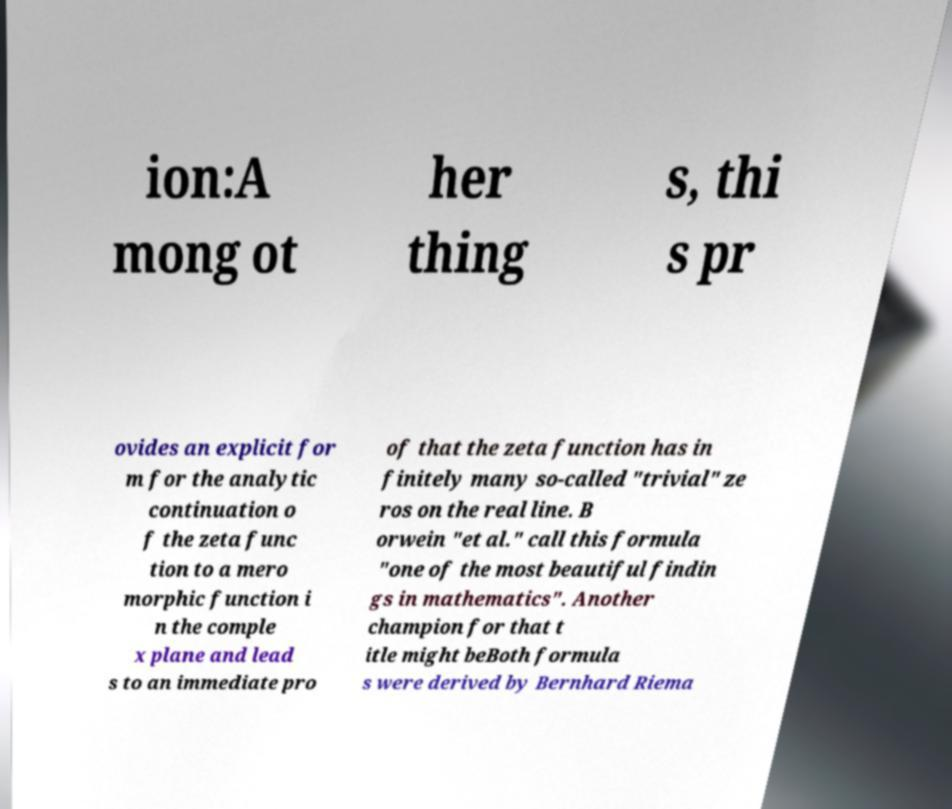For documentation purposes, I need the text within this image transcribed. Could you provide that? ion:A mong ot her thing s, thi s pr ovides an explicit for m for the analytic continuation o f the zeta func tion to a mero morphic function i n the comple x plane and lead s to an immediate pro of that the zeta function has in finitely many so-called "trivial" ze ros on the real line. B orwein "et al." call this formula "one of the most beautiful findin gs in mathematics". Another champion for that t itle might beBoth formula s were derived by Bernhard Riema 